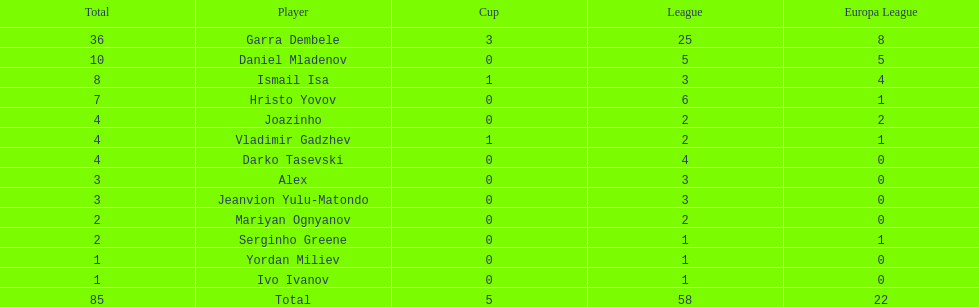Which total is higher, the europa league total or the league total? League. 